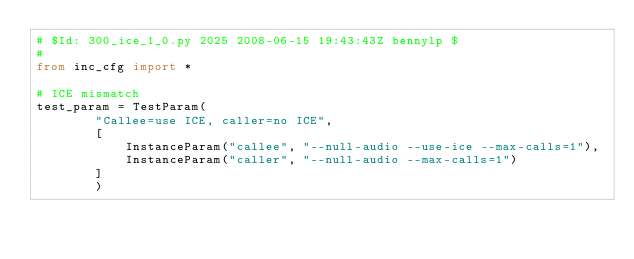<code> <loc_0><loc_0><loc_500><loc_500><_Python_># $Id: 300_ice_1_0.py 2025 2008-06-15 19:43:43Z bennylp $
#
from inc_cfg import *
 
# ICE mismatch
test_param = TestParam(
		"Callee=use ICE, caller=no ICE",
		[
			InstanceParam("callee", "--null-audio --use-ice --max-calls=1"),
			InstanceParam("caller", "--null-audio --max-calls=1")
		]
		)
</code> 